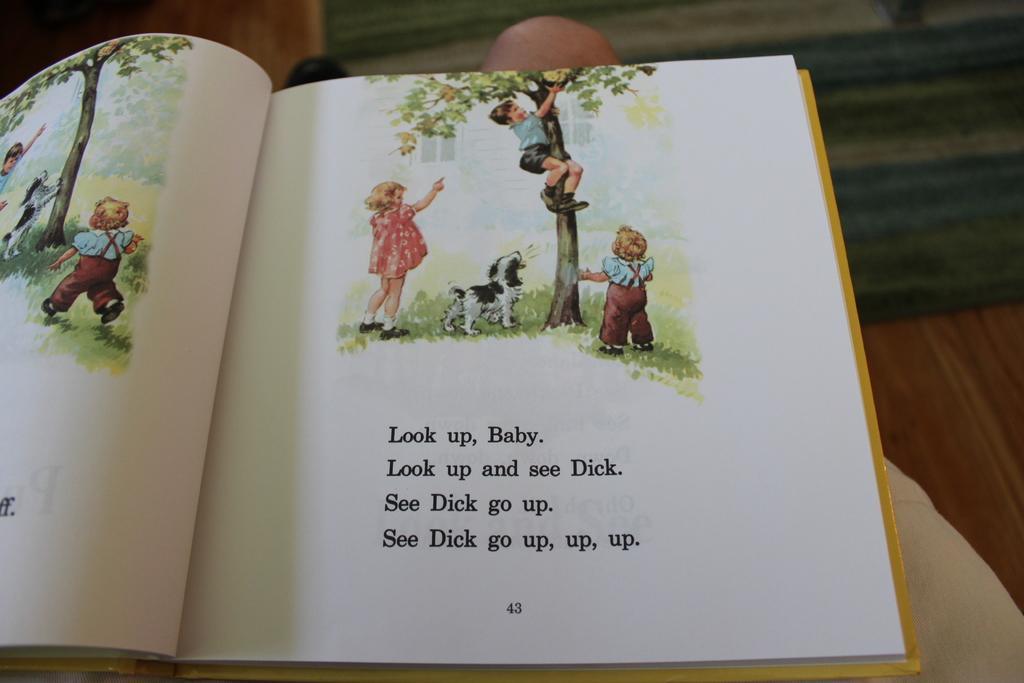Provide a one-sentence caption for the provided image. Page 43 of a book showing a little boy climbing a tree. 